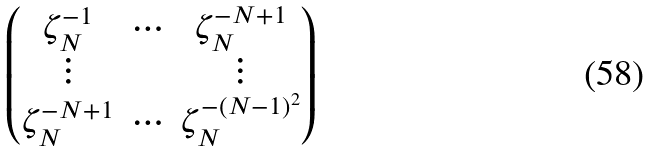Convert formula to latex. <formula><loc_0><loc_0><loc_500><loc_500>\begin{pmatrix} \zeta ^ { - 1 } _ { N } & \cdots & \zeta ^ { - N + 1 } _ { N } \\ \vdots & & \vdots \\ \zeta ^ { - N + 1 } _ { N } & \cdots & \zeta ^ { - ( N - 1 ) ^ { 2 } } _ { N } \end{pmatrix}</formula> 